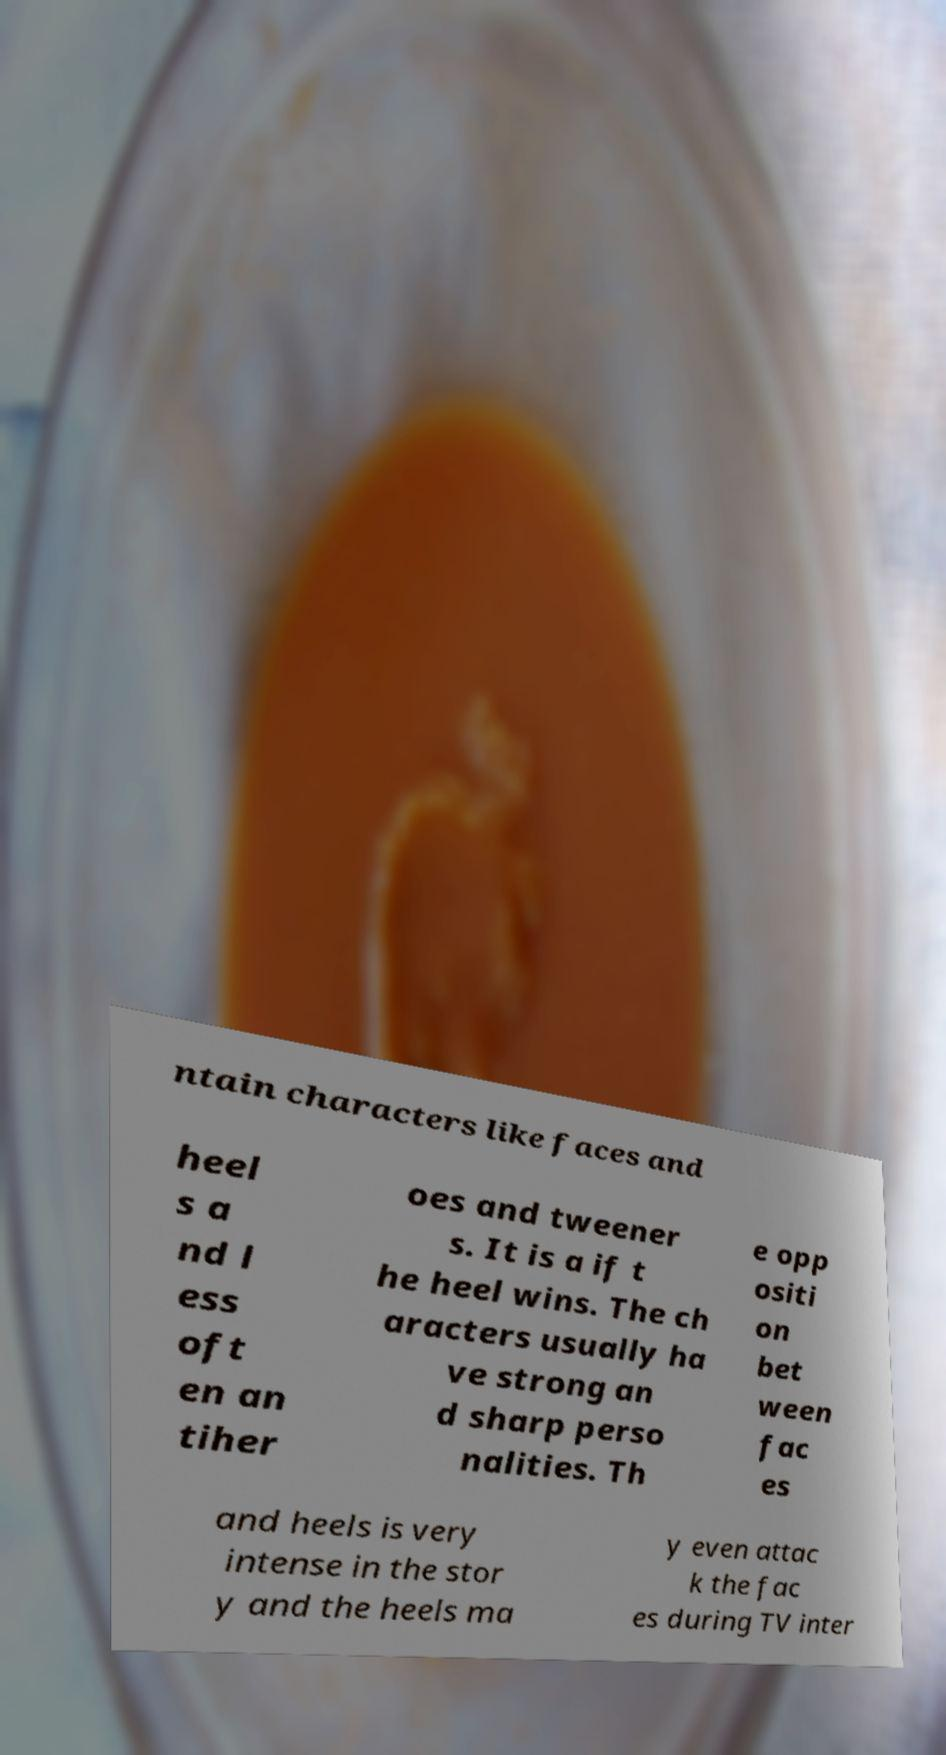There's text embedded in this image that I need extracted. Can you transcribe it verbatim? ntain characters like faces and heel s a nd l ess oft en an tiher oes and tweener s. It is a if t he heel wins. The ch aracters usually ha ve strong an d sharp perso nalities. Th e opp ositi on bet ween fac es and heels is very intense in the stor y and the heels ma y even attac k the fac es during TV inter 